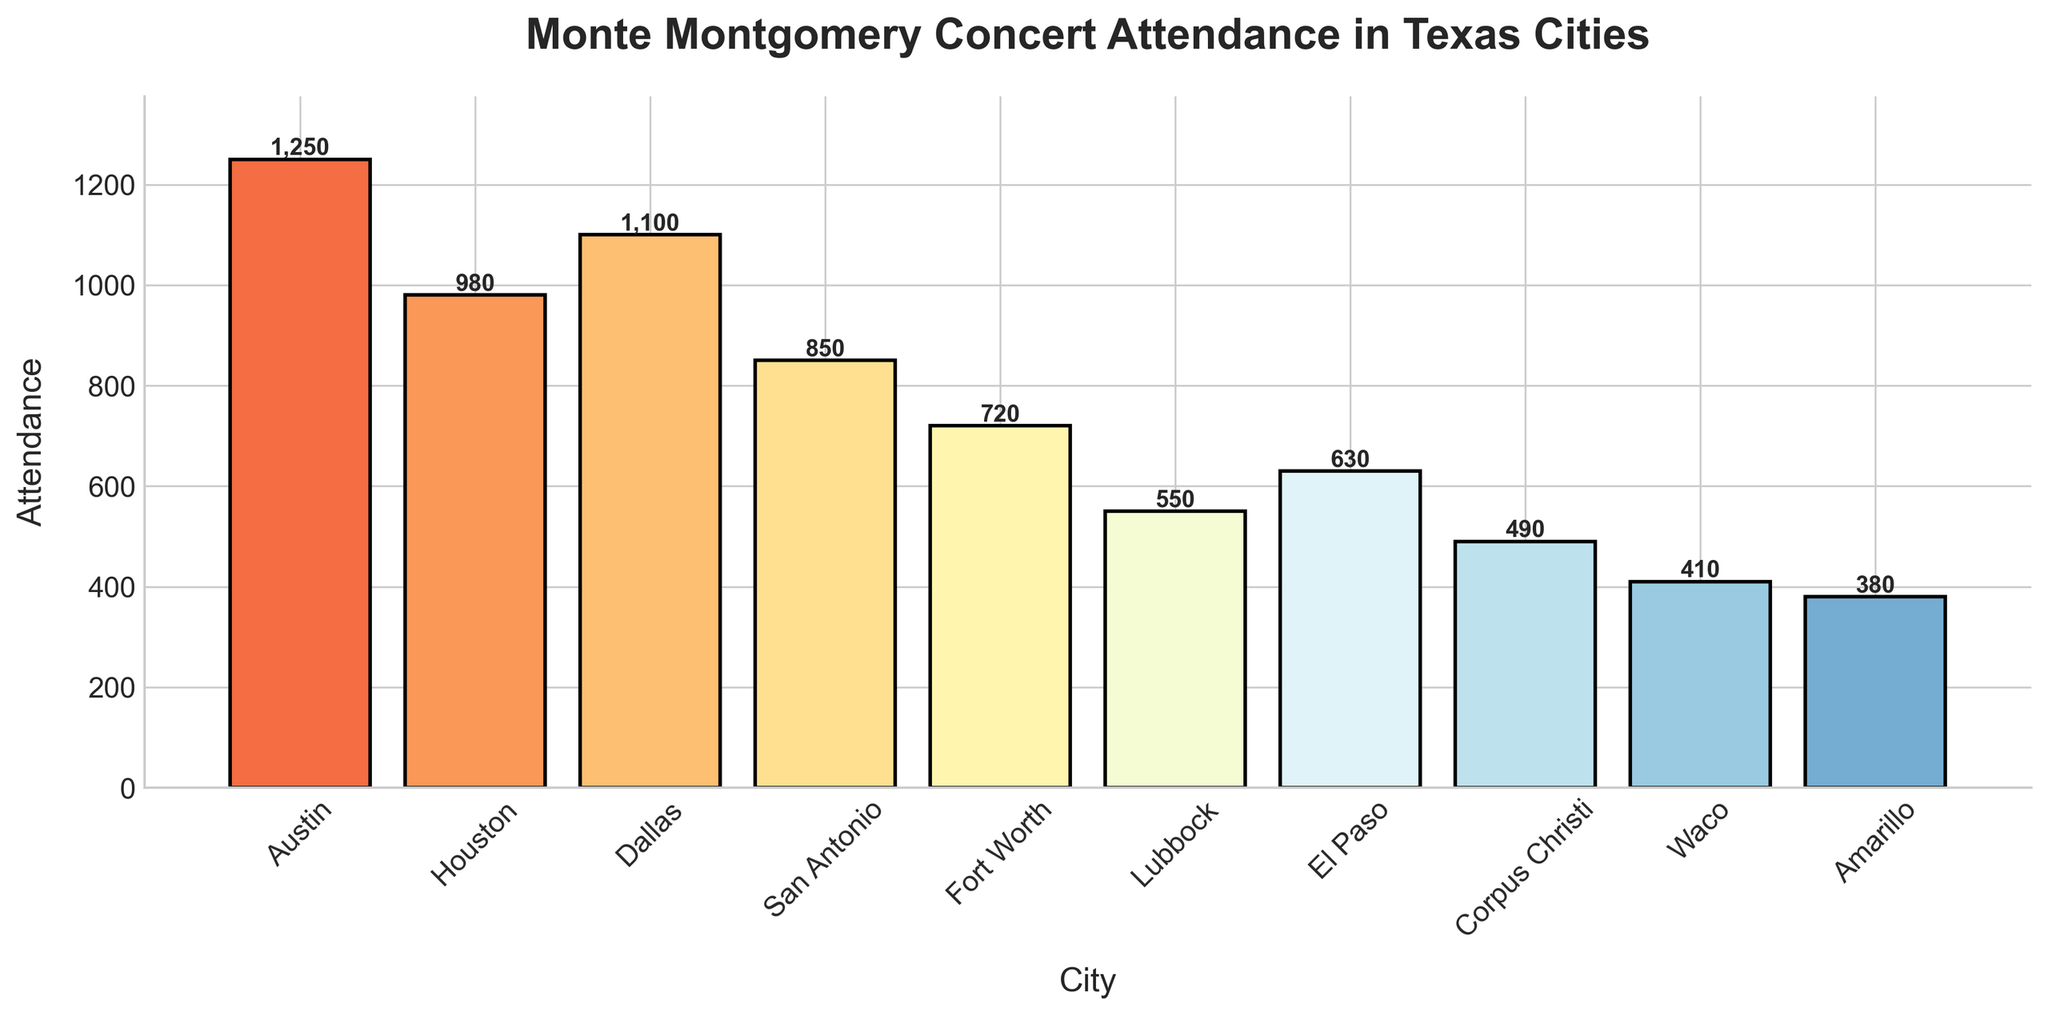Which city had the highest attendance for Monte Montgomery concerts? Comparing the heights of the bars, Austin had the tallest bar, indicating the highest attendance at 1,250.
Answer: Austin What is the difference in attendance between Austin and Fort Worth concerts? The attendance in Austin is 1,250 and in Fort Worth is 720. The difference is 1,250 - 720 = 530.
Answer: 530 Which cities had an attendance greater than 1,000? The bars representing Austin, Dallas, and Houston cross the 1,000 mark. Therefore, cities with attendance greater than 1,000 are Austin, Dallas, and Houston.
Answer: Austin, Dallas, Houston What is the average attendance across all cities? To find the average attendance, sum up the attendance figures (1,250 + 980 + 1,100 + 850 + 720 + 550 + 630 + 490 + 410 + 380) = 7,360, then divide by 10, the number of cities. Thus, the average attendance is 7,360 / 10 = 736.
Answer: 736 Which city had the lowest attendance for Monte Montgomery concerts? By inspecting the heights of the bars, Amarillo has the shortest bar, indicating the lowest attendance at 380.
Answer: Amarillo How much higher is the attendance in Houston compared to that in Lubbock? The attendance in Houston is 980, and in Lubbock is 550. The difference is 980 - 550 = 430.
Answer: 430 What is the total attendance for concerts in cities with less than 500 attendees? The cities with less than 500 attendees are Corpus Christi (490), Waco (410), and Amarillo (380). Summing these up gives 490 + 410 + 380 = 1,280.
Answer: 1,280 Arrange the cities in descending order of attendance. By visually comparing the heights of the bars from the highest to the lowest, the list would be: Austin (1,250), Dallas (1,100), Houston (980), San Antonio (850), Fort Worth (720), El Paso (630), Lubbock (550), Corpus Christi (490), Waco (410), Amarillo (380).
Answer: Austin, Dallas, Houston, San Antonio, Fort Worth, El Paso, Lubbock, Corpus Christi, Waco, Amarillo What is the median attendance across all cities? Organize the attendance figures in ascending order: 380, 410, 490, 550, 630, 720, 850, 980, 1,100, 1,250. With 10 cities, the median is the average of the 5th and 6th values: (630 + 720) / 2 = 675.
Answer: 675 Which city had just over half the attendance of Dallas? Dallas had an attendance of 1,100. To find just over half, we look for nearly 550. Lubbock, with a 550 attendance, fits this description.
Answer: Lubbock 